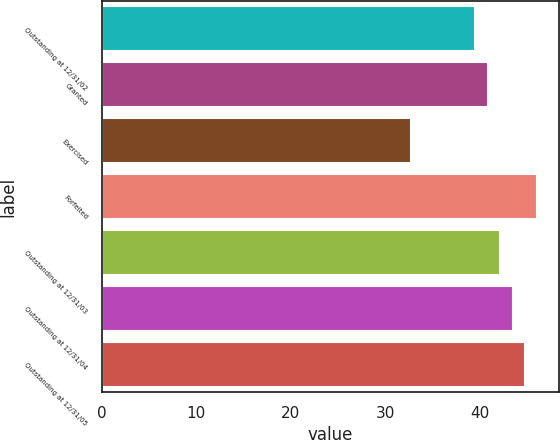Convert chart. <chart><loc_0><loc_0><loc_500><loc_500><bar_chart><fcel>Outstanding at 12/31/02<fcel>Granted<fcel>Exercised<fcel>Forfeited<fcel>Outstanding at 12/31/03<fcel>Outstanding at 12/31/04<fcel>Outstanding at 12/31/05<nl><fcel>39.53<fcel>40.84<fcel>32.7<fcel>46.08<fcel>42.15<fcel>43.46<fcel>44.77<nl></chart> 